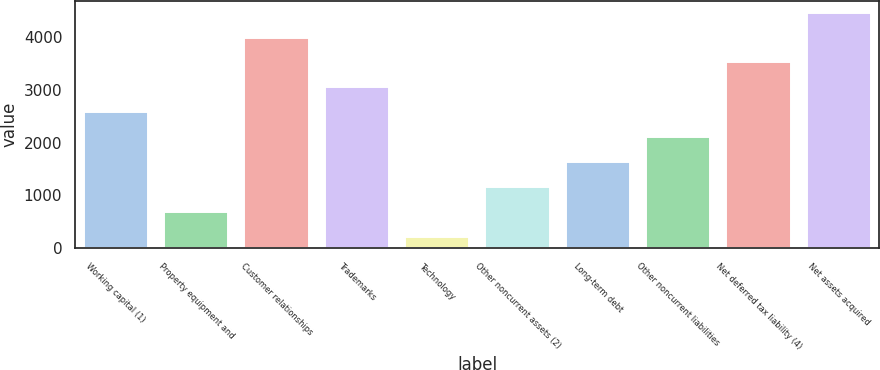Convert chart. <chart><loc_0><loc_0><loc_500><loc_500><bar_chart><fcel>Working capital (1)<fcel>Property equipment and<fcel>Customer relationships<fcel>Trademarks<fcel>Technology<fcel>Other noncurrent assets (2)<fcel>Long-term debt<fcel>Other noncurrent liabilities<fcel>Net deferred tax liability (4)<fcel>Net assets acquired<nl><fcel>2573.5<fcel>686.7<fcel>3988.6<fcel>3045.2<fcel>215<fcel>1158.4<fcel>1630.1<fcel>2101.8<fcel>3516.9<fcel>4460.3<nl></chart> 